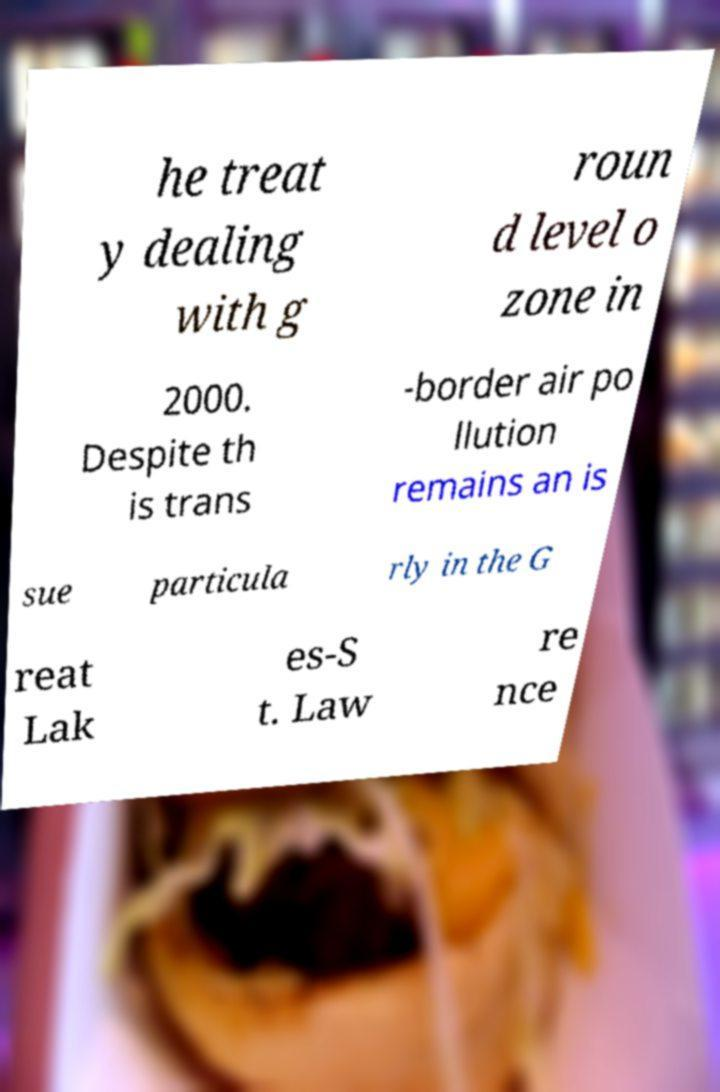Could you extract and type out the text from this image? he treat y dealing with g roun d level o zone in 2000. Despite th is trans -border air po llution remains an is sue particula rly in the G reat Lak es-S t. Law re nce 